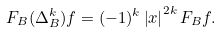<formula> <loc_0><loc_0><loc_500><loc_500>F _ { B } ( \Delta _ { B } ^ { k } ) f = ( - 1 ) ^ { k } \left | x \right | ^ { 2 k } F _ { B } f .</formula> 